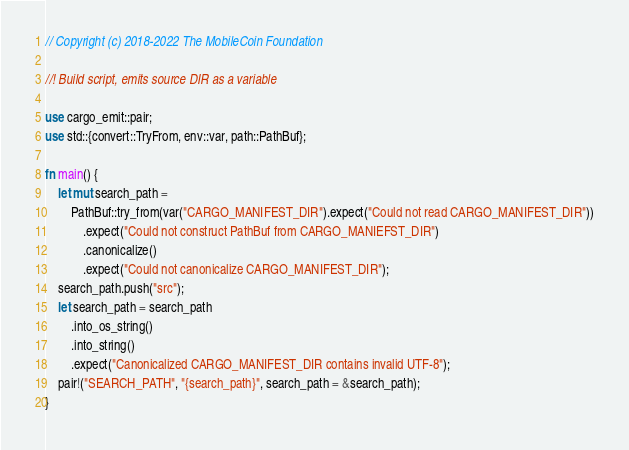Convert code to text. <code><loc_0><loc_0><loc_500><loc_500><_Rust_>// Copyright (c) 2018-2022 The MobileCoin Foundation

//! Build script, emits source DIR as a variable

use cargo_emit::pair;
use std::{convert::TryFrom, env::var, path::PathBuf};

fn main() {
    let mut search_path =
        PathBuf::try_from(var("CARGO_MANIFEST_DIR").expect("Could not read CARGO_MANIFEST_DIR"))
            .expect("Could not construct PathBuf from CARGO_MANIEFST_DIR")
            .canonicalize()
            .expect("Could not canonicalize CARGO_MANIFEST_DIR");
    search_path.push("src");
    let search_path = search_path
        .into_os_string()
        .into_string()
        .expect("Canonicalized CARGO_MANIFEST_DIR contains invalid UTF-8");
    pair!("SEARCH_PATH", "{search_path}", search_path = &search_path);
}
</code> 